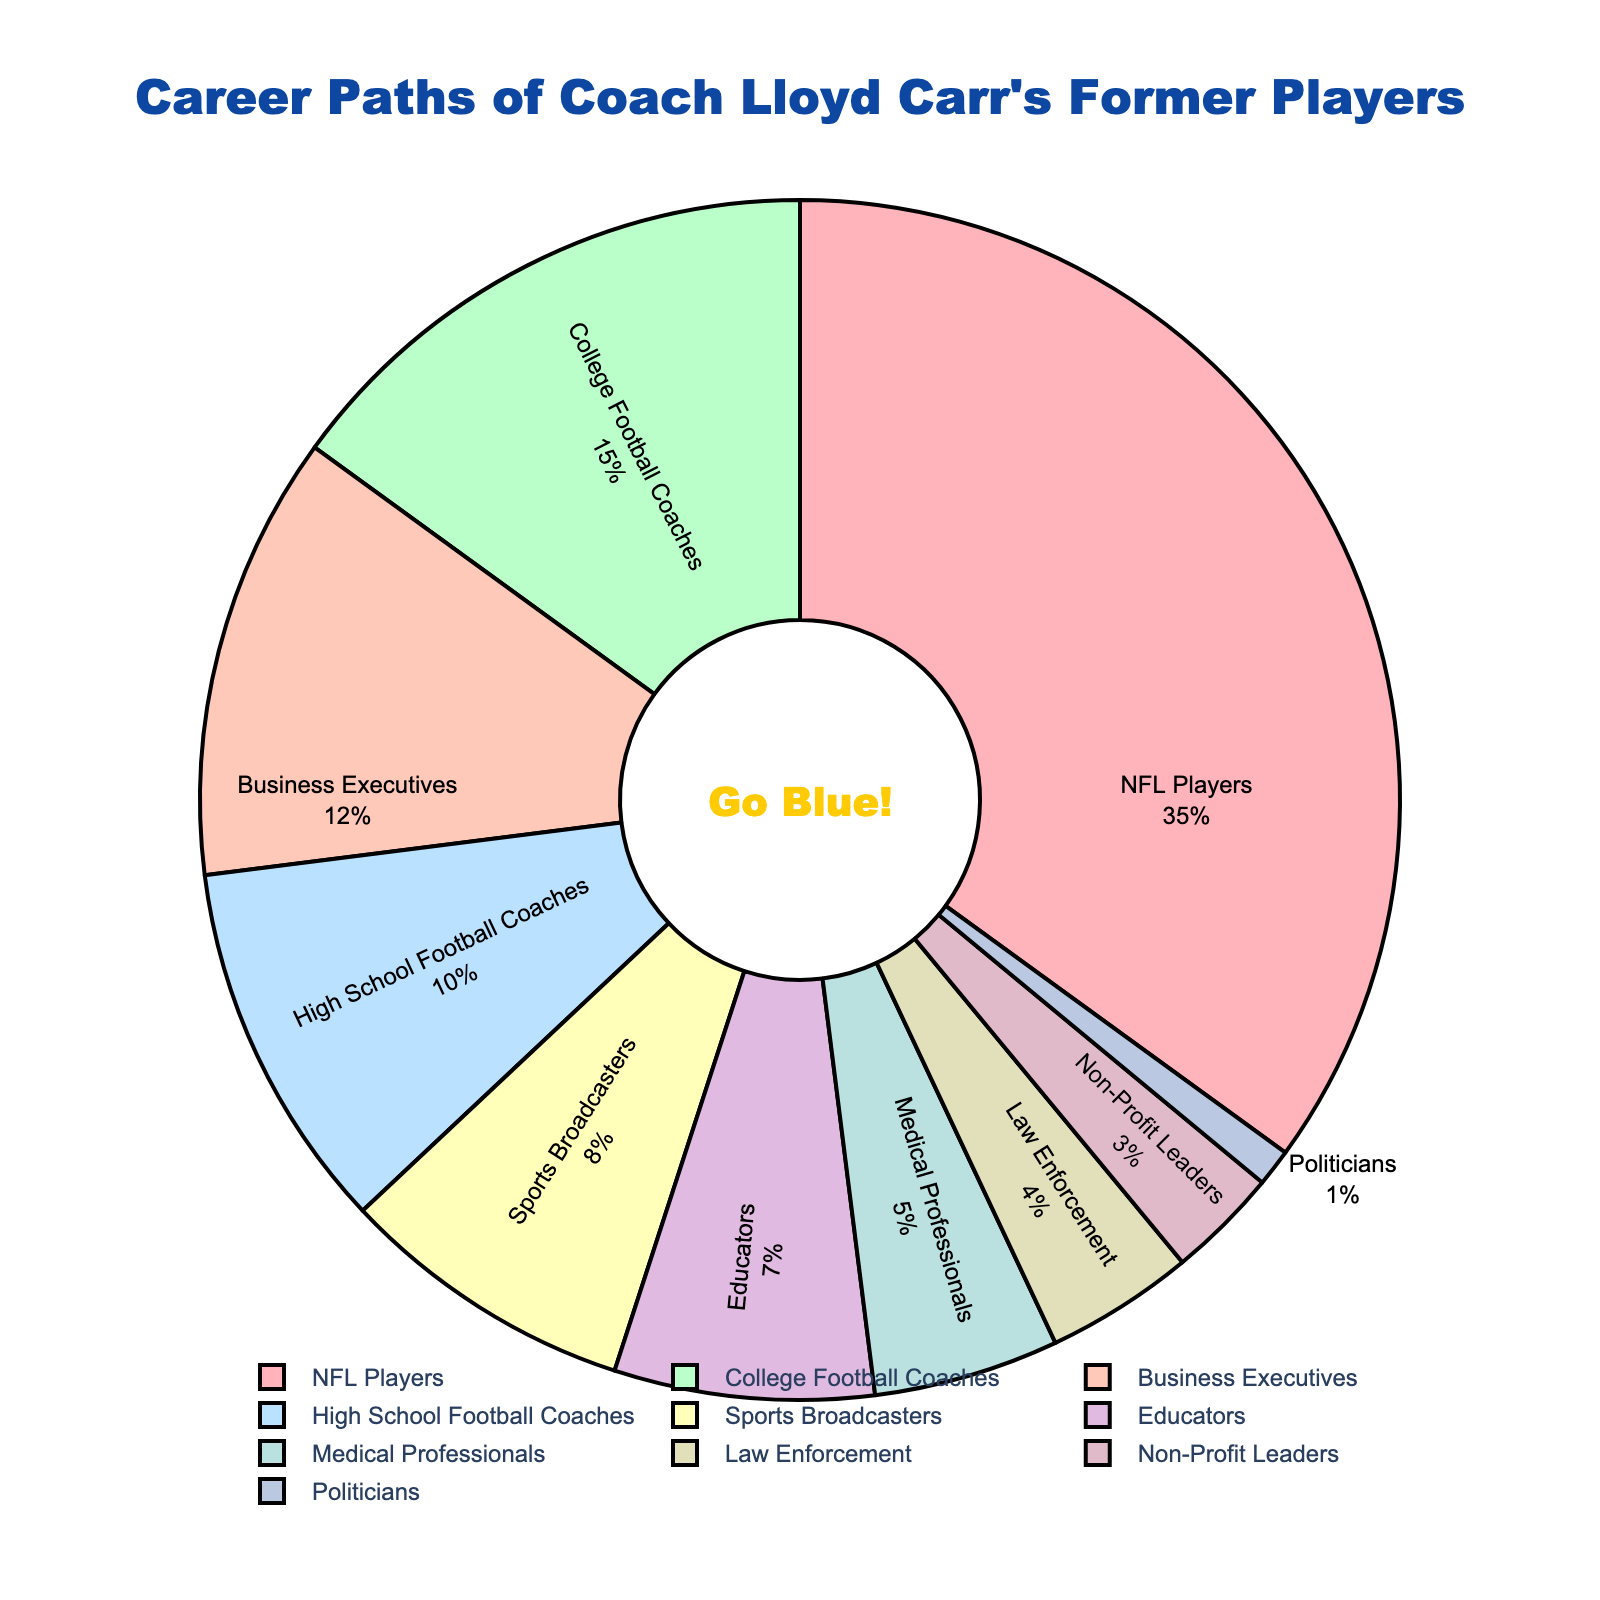What's the total percentage of former players who pursued coaching careers? Add the percentages of College Football Coaches and High School Football Coaches: 15% (College Football Coaches) + 10% (High School Football Coaches) = 25%.
Answer: 25% What is the most popular career path for Coach Lloyd Carr's former players? The largest percentage segment in the pie chart is for NFL Players, which is 35%.
Answer: NFL Players How many career paths have less than 10% of the former players? Identify segments with percentages less than 10%: High School Football Coaches (10% - equal, so not included), Sports Broadcasters (8%), Educators (7%), Medical Professionals (5%), Law Enforcement (4%), Non-Profit Leaders (3%), Politicians (1%). This gives us 6 paths.
Answer: 6 Which career path is represented by the light blue segment in the pie chart? Visually identify the light blue color associated with the "Sports Broadcasters" in the pie chart.
Answer: Sports Broadcasters Is the percentage of former players who became Business Executives greater than that of those who became Coaches? Compare the percentages: Business Executives (12%) vs. sum of College Football Coaches (15%) and High School Football Coaches (10%) = 25%. Business Executives (12%) is not greater.
Answer: No What's the combined percentage of former players who pursued careers in the medical and law enforcement fields? Add the percentages of Medical Professionals and Law Enforcement: 5% (Medical Professionals) + 4% (Law Enforcement) = 9%.
Answer: 9% Does the percentage of former NFL players exceed the total percentage of those in business-related fields (Business Executives + Politicians)? Compare NFL Players (35%) with the sum of Business Executives (12%) and Politicians (1%) = 13%. 35% is greater than 13%.
Answer: Yes Which is the least pursued career path among Coach Lloyd Carr's former players? Identify the smallest segment in the pie chart, which is Politicians at 1%.
Answer: Politicians By how much does the percentage of NFL Players surpass the combined percentage of Educators and Non-Profit Leaders? Calculate the combined percentage of Educators and Non-Profit Leaders: 7% (Educators) + 3% (Non-Profit Leaders) = 10%. Then, subtract this sum from NFL Players (35%): 35% - 10% = 25%.
Answer: 25% What proportion of former players pursued a sports-related career (NFL Players, College Football Coaches, High School Football Coaches, Sports Broadcasters)? Add relevant percentages: NFL Players (35%) + College Football Coaches (15%) + High School Football Coaches (10%) + Sports Broadcasters (8%) = 68%.
Answer: 68% 